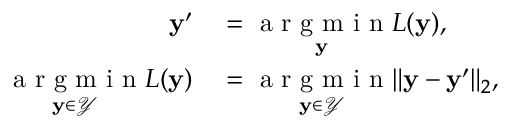<formula> <loc_0><loc_0><loc_500><loc_500>\begin{array} { r l } { y ^ { \prime } } & = \underset { y } { a r g m i n } L ( y ) , } \\ { \underset { y \in \mathcal { Y } } { a r g m i n } L ( y ) } & = \underset { y \in \mathcal { Y } } { a r g m i n } \| y - y ^ { \prime } \| _ { 2 } , } \end{array}</formula> 